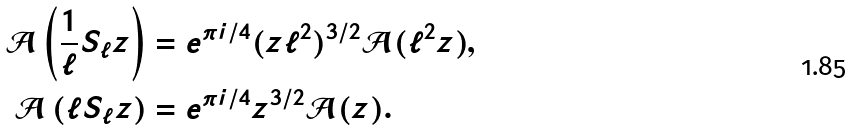Convert formula to latex. <formula><loc_0><loc_0><loc_500><loc_500>\mathcal { A } \left ( \frac { 1 } { \ell } S _ { \ell } z \right ) & = e ^ { \pi i / 4 } ( z \ell ^ { 2 } ) ^ { 3 / 2 } \mathcal { A } ( \ell ^ { 2 } z ) , \\ \mathcal { A } \left ( \ell S _ { \ell } z \right ) & = e ^ { \pi i / 4 } z ^ { 3 / 2 } \mathcal { A } ( z ) .</formula> 